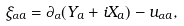<formula> <loc_0><loc_0><loc_500><loc_500>\xi _ { \alpha a } = \partial _ { \alpha } ( Y _ { a } + i X _ { a } ) - u _ { \alpha a } ,</formula> 